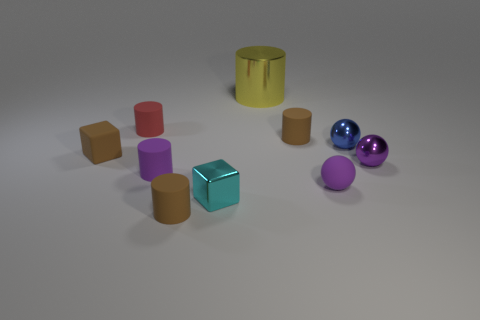Is there any other thing that is the same material as the cyan cube?
Your answer should be very brief. Yes. There is a small purple object that is the same shape as the big metallic object; what is its material?
Offer a terse response. Rubber. Are there the same number of tiny purple balls in front of the purple matte ball and large metal cylinders?
Give a very brief answer. No. There is a brown rubber thing that is left of the cyan metallic thing and behind the cyan cube; what is its size?
Keep it short and to the point. Small. Is there anything else of the same color as the large thing?
Your response must be concise. No. There is a purple shiny sphere that is to the right of the tiny purple thing on the left side of the purple matte sphere; how big is it?
Ensure brevity in your answer.  Small. The tiny rubber object that is behind the brown block and on the right side of the red matte thing is what color?
Provide a short and direct response. Brown. How many other things are the same size as the cyan metallic thing?
Make the answer very short. 8. There is a purple metallic sphere; does it have the same size as the metal thing on the left side of the metallic cylinder?
Ensure brevity in your answer.  Yes. There is a shiny sphere that is the same size as the purple shiny thing; what color is it?
Ensure brevity in your answer.  Blue. 